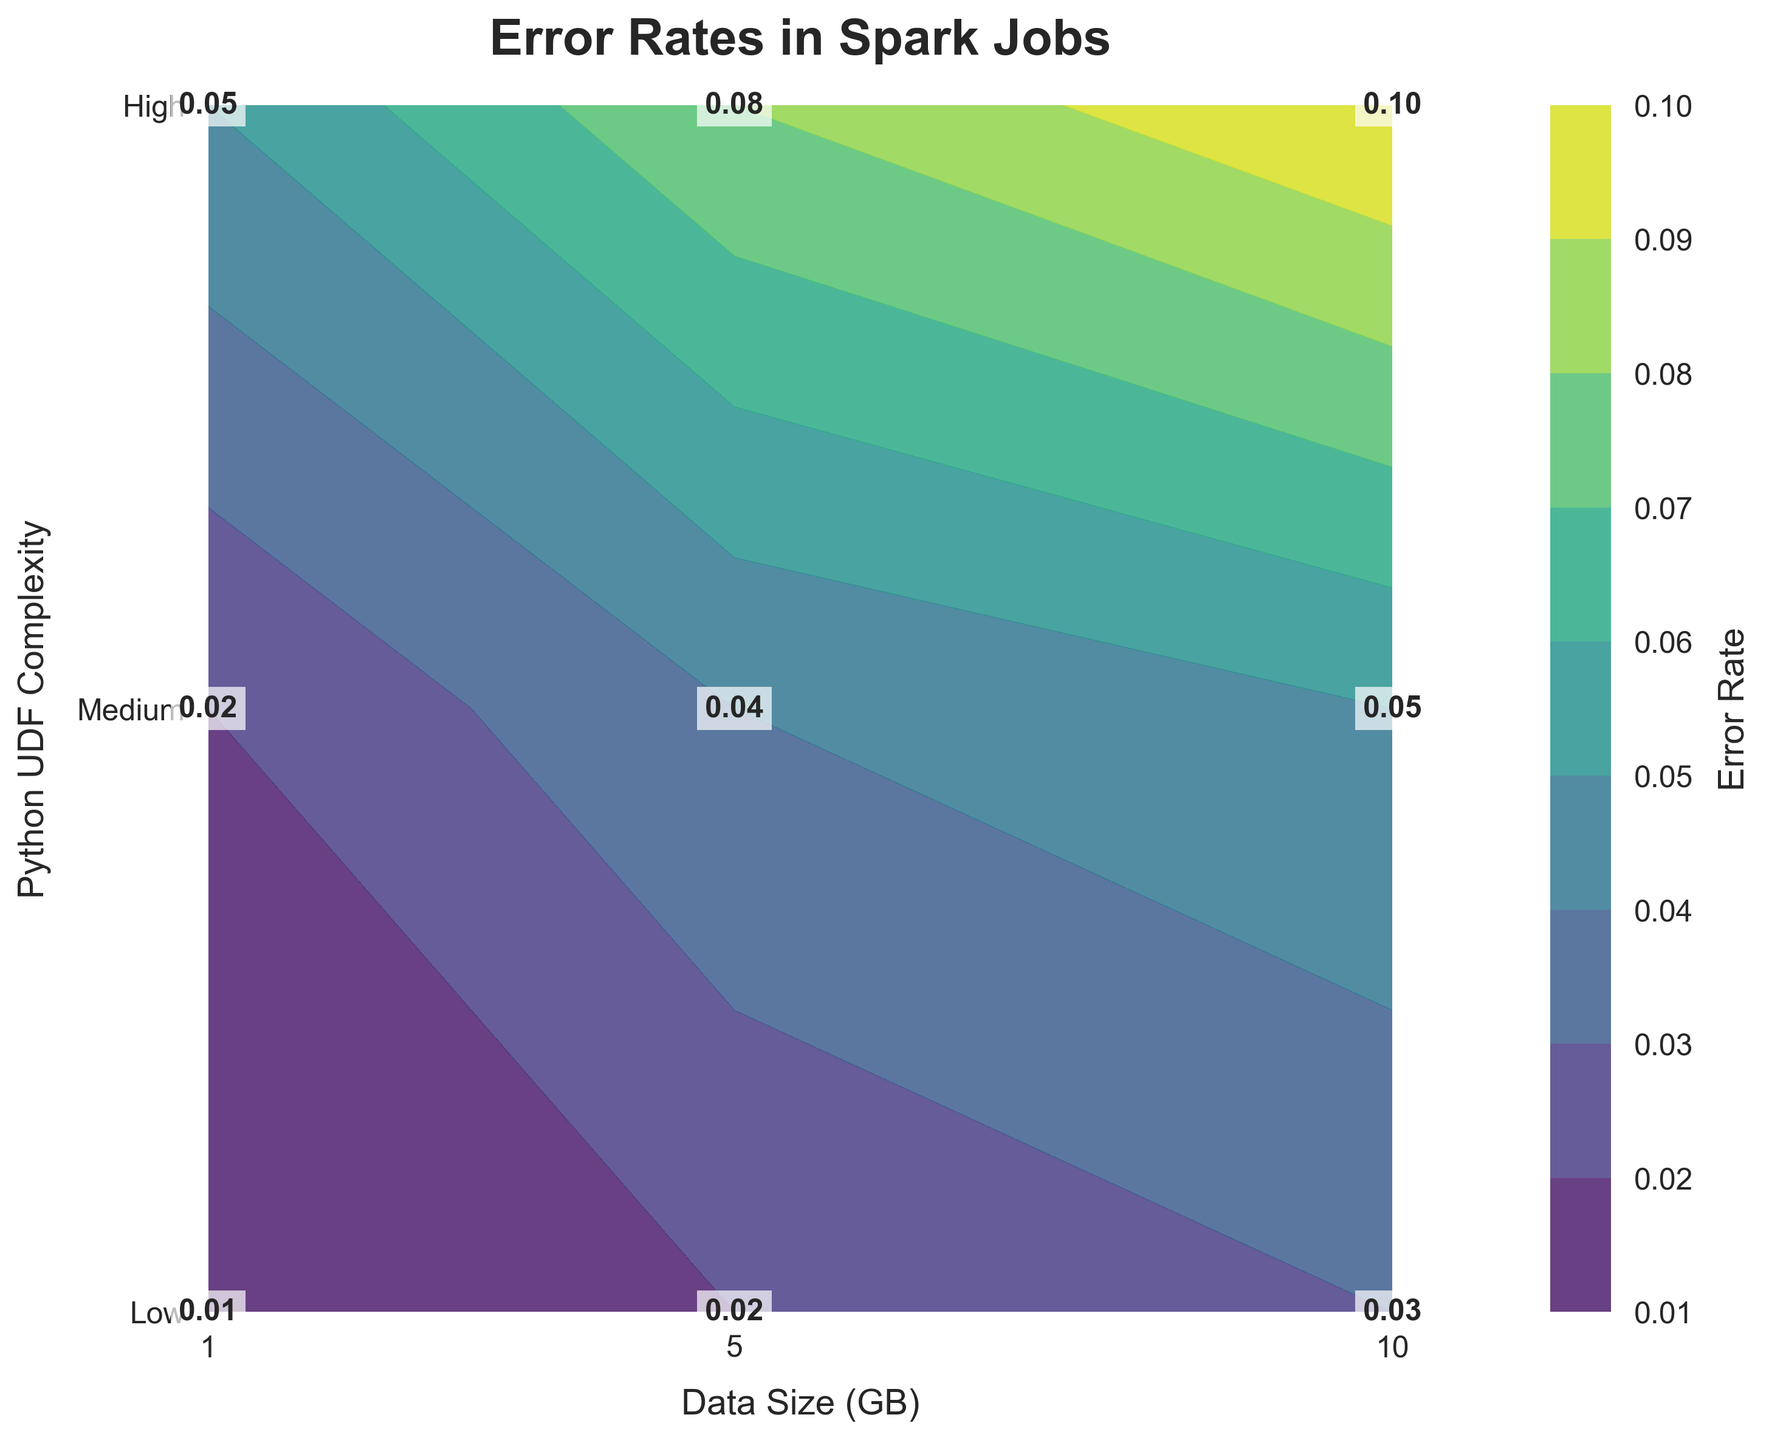What is the title of the plot? The title is usually located at the top center of the plot and is formatted in a larger, bold font.
Answer: Error Rates in Spark Jobs What are the labels for the x-axis and y-axis? Axis labels describe what data is represented on each axis. The x-axis focuses on "Data Size (GB)" and the y-axis on "Python UDF Complexity".
Answer: Data Size (GB) and Python UDF Complexity How many different Python UDF Complexities are represented in the plot? The y-axis shows ticks and labels for different levels of Python UDF Complexity. There are three labels: "Low", "Medium", and "High".
Answer: Three Which Data Size (GB) corresponds to the highest Error Rate? Identify the maximum value in the color gradient of the plot and find the corresponding data size along the x-axis. The highest error rate, 0.10, corresponds to 10 GB.
Answer: 10 GB What's the error rate for Medium complexity at 5 GB data size? Locate the Medium complexity along the y-axis, follow it horizontally to the 5 GB mark on the x-axis, and read the value inside the contour plot.
Answer: 0.04 Compare the error rates for Low and High complexities at 1 GB Identify the error rates at 1 GB for both Low and High complexity levels. The values are 0.01 and 0.05, respectively.
Answer: Low: 0.01, High: 0.05 What is the trend in error rate as Data Size increases for Medium Python UDF complexity? Trace the horizontal path of Medium complexity on the y-axis and observe the error rate values as Data Size scales from 1 GB to 10 GB. The values increase from 0.02 to 0.05.
Answer: Increases What is the difference in error rate between Low and Medium UDF complexities for 10 GB data size? Compare the values at the 10 GB mark for both Low (0.03) and Medium (0.05) complexities and compute the difference.
Answer: 0.02 What is the average error rate for High UDF complexity? Sum the error rates for High complexity (0.05 + 0.08 + 0.10) and divide by the number of data points (3).
Answer: 0.0767 Which combination of Data Size (GB) and Python UDF complexity yields the lowest Error Rate? Identify the smallest value in the contour plot and its corresponding coordinates. The lowest error rate, 0.01, appears at Low complexity for 1 GB.
Answer: Low complexity, 1 GB 